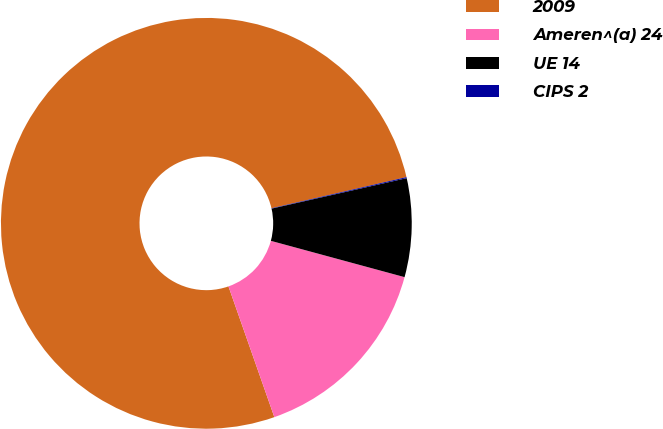<chart> <loc_0><loc_0><loc_500><loc_500><pie_chart><fcel>2009<fcel>Ameren^(a) 24<fcel>UE 14<fcel>CIPS 2<nl><fcel>76.76%<fcel>15.41%<fcel>7.75%<fcel>0.08%<nl></chart> 